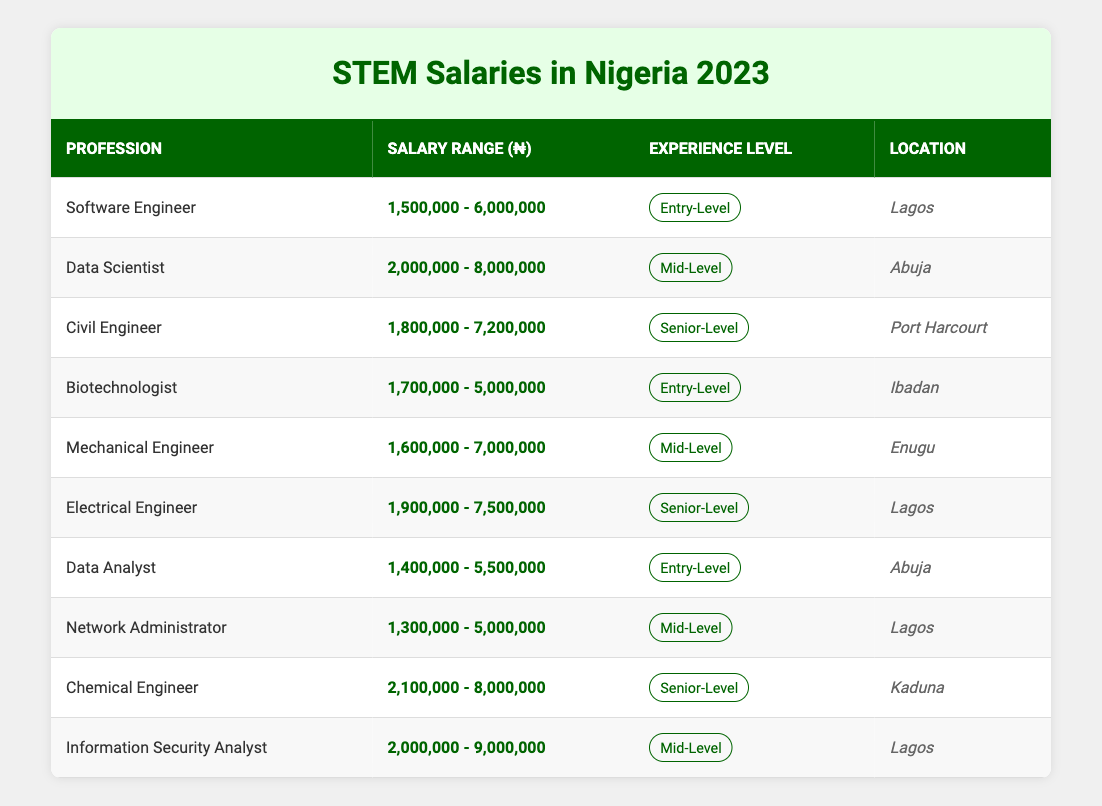What is the salary range for a Software Engineer? The table shows that the salary range for a Software Engineer is between ₦1,500,000 and ₦6,000,000.
Answer: ₦1,500,000 - ₦6,000,000 Which profession offers the highest maximum salary? By examining the maximum salary values across all professions, the Information Security Analyst has the highest maximum salary at ₦9,000,000.
Answer: Information Security Analyst What is the average minimum salary for Entry-Level positions? The minimum salaries for Entry-Level positions are ₦1,500,000 (Software Engineer), ₦1,700,000 (Biotechnologist), and ₦1,400,000 (Data Analyst), totaling ₦4,600,000. Since there are three Entry-Level positions, the average is ₦4,600,000 ÷ 3 = ₦1,533,333.33.
Answer: ₦1,533,333.33 Are there any professions located in Enugu? The table lists Mechanical Engineer as a profession located in Enugu, confirming its presence in the location.
Answer: Yes What is the difference between the minimum salary of a Chemical Engineer and that of a Network Administrator? The minimum salary for a Chemical Engineer is ₦2,100,000 and for a Network Administrator is ₦1,300,000. The difference is ₦2,100,000 - ₦1,300,000 = ₦800,000.
Answer: ₦800,000 How many professions have a maximum salary over ₦7,000,000? The professions with maximum salaries over ₦7,000,000 are Data Scientist (₦8,000,000), Chemical Engineer (₦8,000,000), and Information Security Analyst (₦9,000,000). There are three such professions.
Answer: 3 Which profession has the lowest minimum salary? Comparing all the minimum salary values, the lowest is for Network Administrator at ₦1,300,000.
Answer: Network Administrator If considering only Senior-Level positions, which profession has the highest salary range? The maximum salaries for Senior-Level positions are ₦7,200,000 (Civil Engineer), ₦7,500,000 (Electrical Engineer), and ₦8,000,000 (Chemical Engineer). The highest is for Chemical Engineer at ₦8,000,000.
Answer: Chemical Engineer What is the total salary range for all listed professions? Summing up the maximum salaries: ₦6,000,000 (Software Engineer) + ₦8,000,000 (Data Scientist) + ₦7,200,000 (Civil Engineer) + ₦5,000,000 (Biotechnologist) + ₦7,000,000 (Mechanical Engineer) + ₦7,500,000 (Electrical Engineer) + ₦5,500,000 (Data Analyst) + ₦5,000,000 (Network Administrator) + ₦8,000,000 (Chemical Engineer) + ₦9,000,000 (Information Security Analyst) = ₦69,200,000. Therefore, the total salary range spans from ₦1,300,000 to ₦9,000,000.
Answer: ₦1,300,000 - ₦9,000,000 Is there a profession listed in Ibadan? Yes, the table specifies Biotechnologist as a profession located in Ibadan.
Answer: Yes 